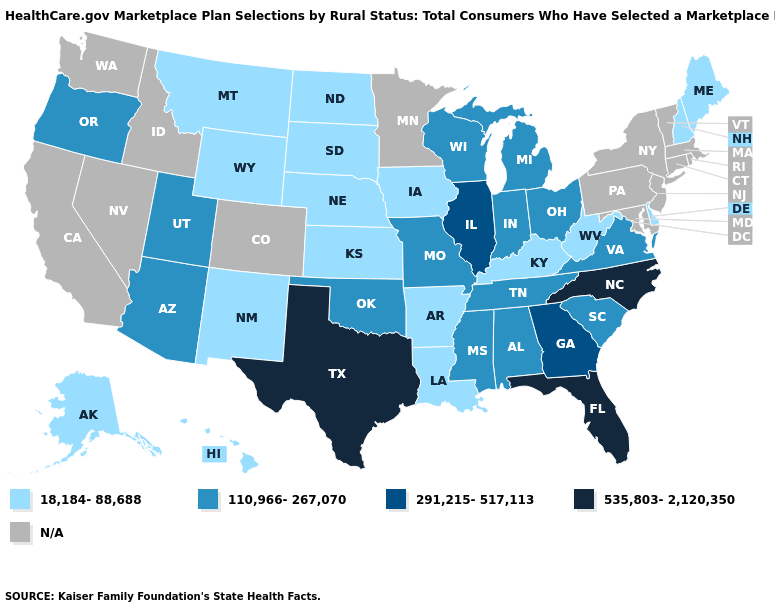Is the legend a continuous bar?
Give a very brief answer. No. Which states have the lowest value in the West?
Write a very short answer. Alaska, Hawaii, Montana, New Mexico, Wyoming. Does Louisiana have the lowest value in the South?
Short answer required. Yes. Name the states that have a value in the range 18,184-88,688?
Concise answer only. Alaska, Arkansas, Delaware, Hawaii, Iowa, Kansas, Kentucky, Louisiana, Maine, Montana, Nebraska, New Hampshire, New Mexico, North Dakota, South Dakota, West Virginia, Wyoming. Does Illinois have the highest value in the USA?
Keep it brief. No. Name the states that have a value in the range 291,215-517,113?
Write a very short answer. Georgia, Illinois. Name the states that have a value in the range 291,215-517,113?
Short answer required. Georgia, Illinois. What is the value of Alaska?
Concise answer only. 18,184-88,688. Is the legend a continuous bar?
Short answer required. No. Which states have the lowest value in the USA?
Answer briefly. Alaska, Arkansas, Delaware, Hawaii, Iowa, Kansas, Kentucky, Louisiana, Maine, Montana, Nebraska, New Hampshire, New Mexico, North Dakota, South Dakota, West Virginia, Wyoming. What is the lowest value in states that border South Carolina?
Concise answer only. 291,215-517,113. Does Arkansas have the highest value in the South?
Write a very short answer. No. What is the value of South Dakota?
Answer briefly. 18,184-88,688. 